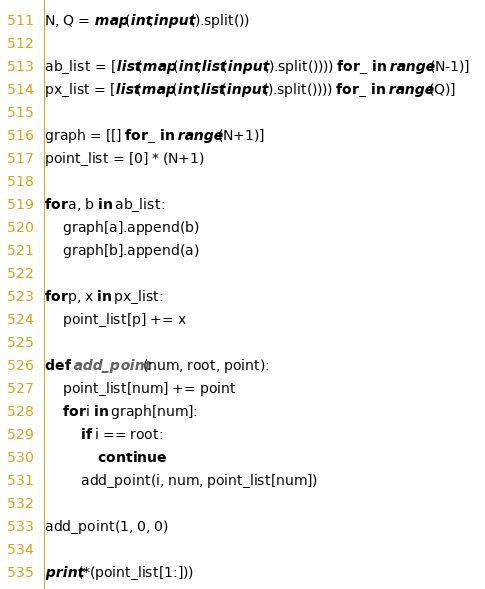<code> <loc_0><loc_0><loc_500><loc_500><_Python_>N, Q = map(int,input().split())

ab_list = [list(map(int,list(input().split()))) for _ in range(N-1)]  
px_list = [list(map(int,list(input().split()))) for _ in range(Q)]  

graph = [[] for _ in range(N+1)]
point_list = [0] * (N+1)

for a, b in ab_list:
    graph[a].append(b)
    graph[b].append(a)
    
for p, x in px_list:
    point_list[p] += x
    
def add_point(num, root, point):
    point_list[num] += point
    for i in graph[num]:
        if i == root:
            continue
        add_point(i, num, point_list[num])

add_point(1, 0, 0)
 
print(*(point_list[1:]))</code> 